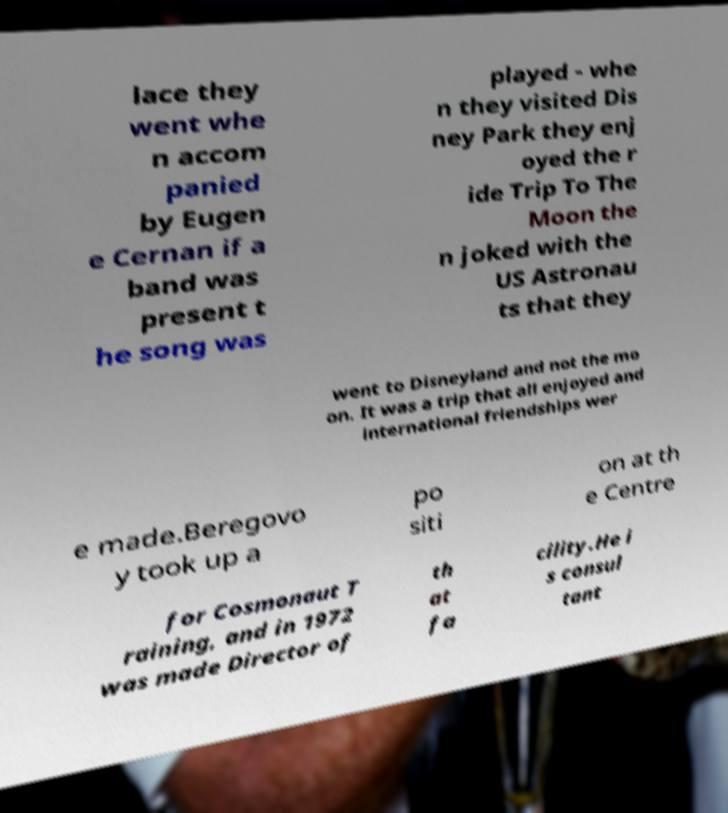There's text embedded in this image that I need extracted. Can you transcribe it verbatim? lace they went whe n accom panied by Eugen e Cernan if a band was present t he song was played - whe n they visited Dis ney Park they enj oyed the r ide Trip To The Moon the n joked with the US Astronau ts that they went to Disneyland and not the mo on. It was a trip that all enjoyed and international friendships wer e made.Beregovo y took up a po siti on at th e Centre for Cosmonaut T raining, and in 1972 was made Director of th at fa cility.He i s consul tant 